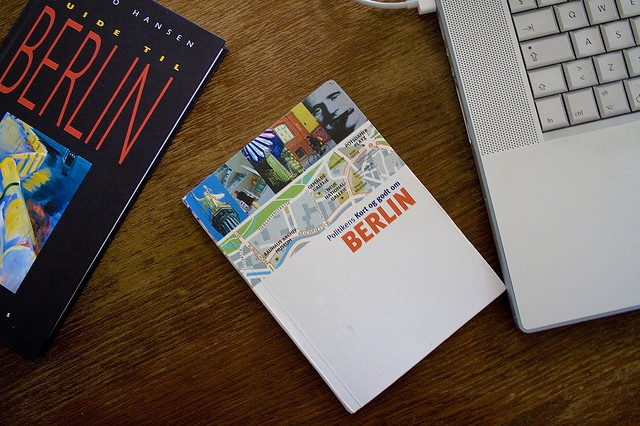Describe the objects in this image and their specific colors. I can see book in black, lightgray, darkgray, and gray tones, laptop in black, darkgray, gray, and lightgray tones, book in black, brown, blue, and navy tones, and keyboard in black, darkgray, gray, and lightgray tones in this image. 